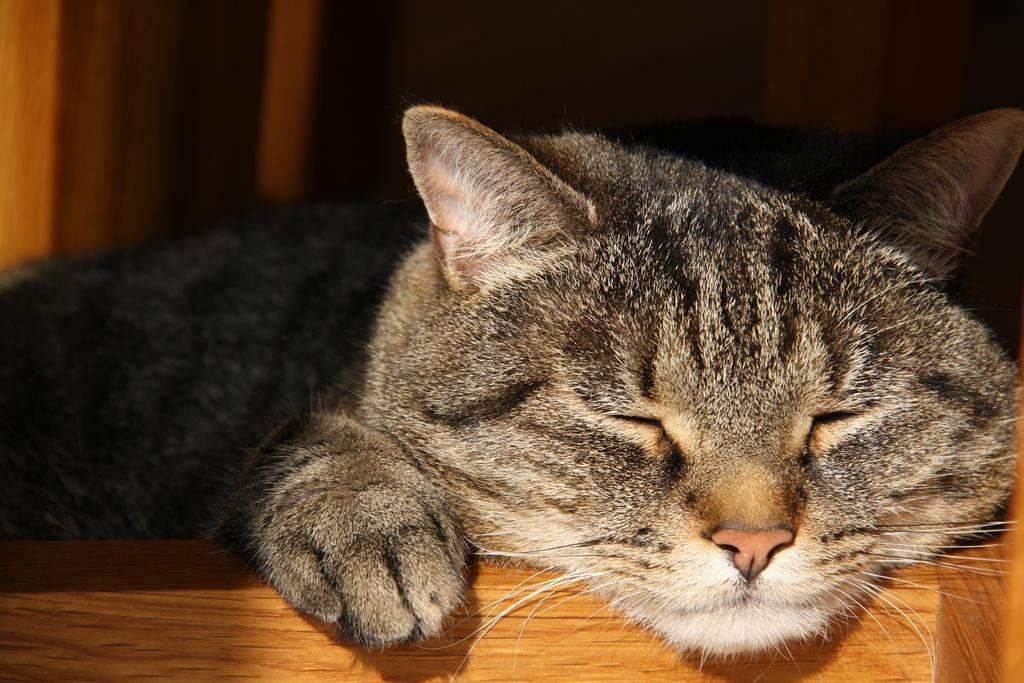What animal is present in the image? There is a cat in the image. What is the cat lying on? The cat is lying on a wooden surface. How would you describe the background of the image? The background of the image is dark. What type of sugar is being used by the cat in the image? There is no sugar present in the image; it features a cat lying on a wooden surface with a dark background. 